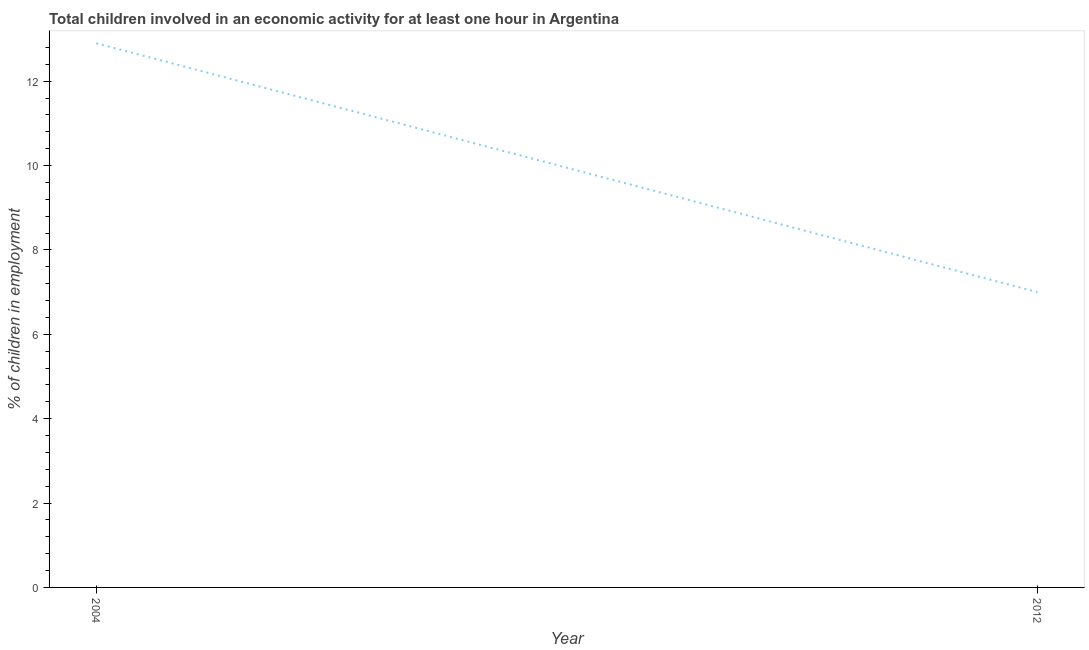In which year was the percentage of children in employment minimum?
Your answer should be compact. 2012. What is the sum of the percentage of children in employment?
Provide a short and direct response. 19.9. What is the difference between the percentage of children in employment in 2004 and 2012?
Provide a succinct answer. 5.9. What is the average percentage of children in employment per year?
Give a very brief answer. 9.95. What is the median percentage of children in employment?
Provide a short and direct response. 9.95. What is the ratio of the percentage of children in employment in 2004 to that in 2012?
Your response must be concise. 1.84. Does the percentage of children in employment monotonically increase over the years?
Your response must be concise. No. How many years are there in the graph?
Provide a succinct answer. 2. What is the difference between two consecutive major ticks on the Y-axis?
Your response must be concise. 2. Are the values on the major ticks of Y-axis written in scientific E-notation?
Your response must be concise. No. Does the graph contain any zero values?
Provide a succinct answer. No. Does the graph contain grids?
Offer a very short reply. No. What is the title of the graph?
Provide a short and direct response. Total children involved in an economic activity for at least one hour in Argentina. What is the label or title of the X-axis?
Your answer should be compact. Year. What is the label or title of the Y-axis?
Offer a terse response. % of children in employment. What is the % of children in employment in 2012?
Your answer should be compact. 7. What is the ratio of the % of children in employment in 2004 to that in 2012?
Your answer should be compact. 1.84. 